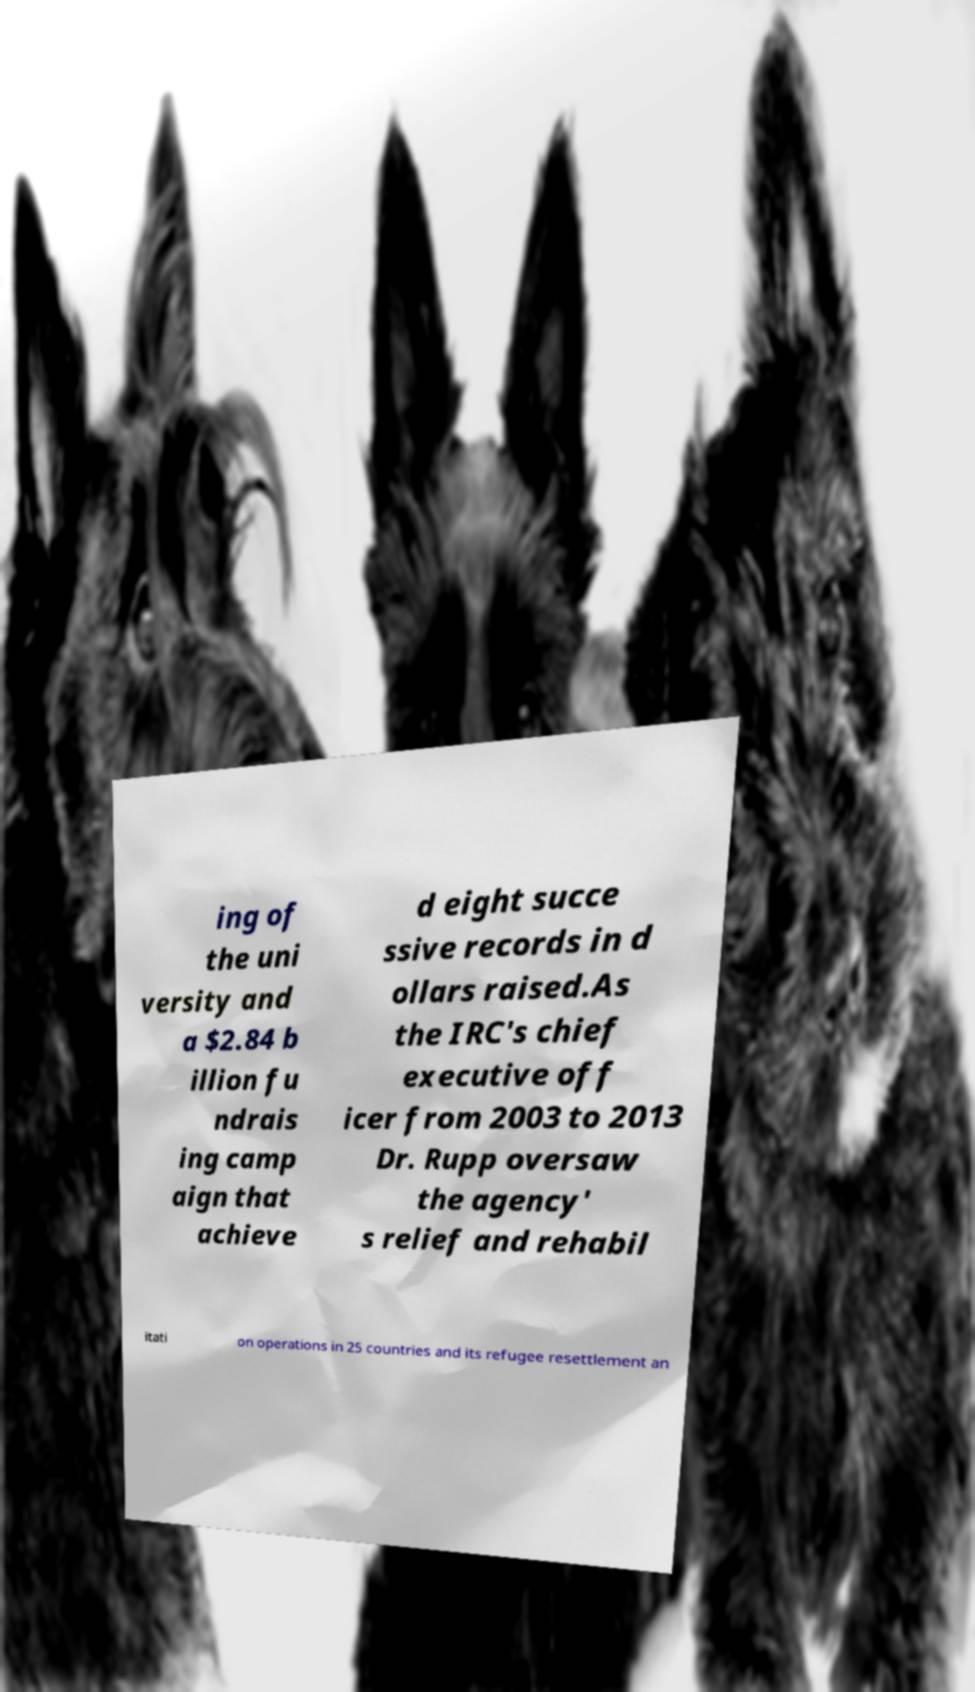Could you extract and type out the text from this image? ing of the uni versity and a $2.84 b illion fu ndrais ing camp aign that achieve d eight succe ssive records in d ollars raised.As the IRC's chief executive off icer from 2003 to 2013 Dr. Rupp oversaw the agency' s relief and rehabil itati on operations in 25 countries and its refugee resettlement an 